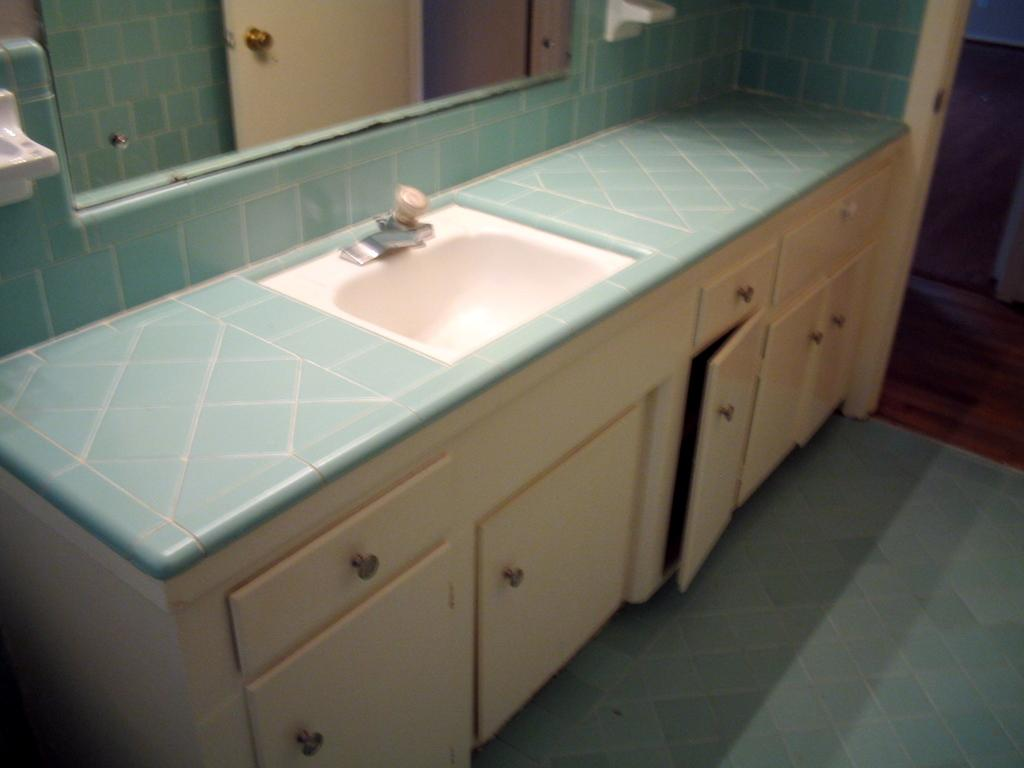What type of fixture is present in the image? There is a sink in the image. What other furniture or fixtures can be seen at the bottom of the image? There are cupboards at the bottom of the image. What is visible in the background of the image? There is a mirror in the background of the image. How does the crow interact with the sink in the image? There is no crow present in the image, so it cannot interact with the sink. 